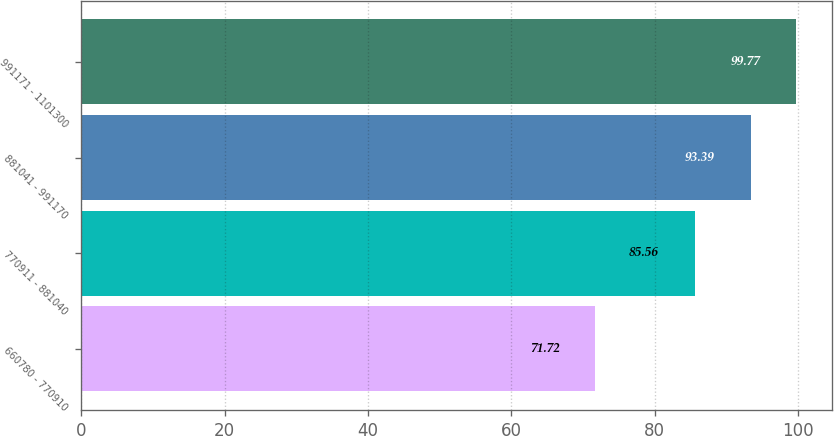<chart> <loc_0><loc_0><loc_500><loc_500><bar_chart><fcel>660780 - 770910<fcel>770911 - 881040<fcel>881041 - 991170<fcel>991171 - 1101300<nl><fcel>71.72<fcel>85.56<fcel>93.39<fcel>99.77<nl></chart> 